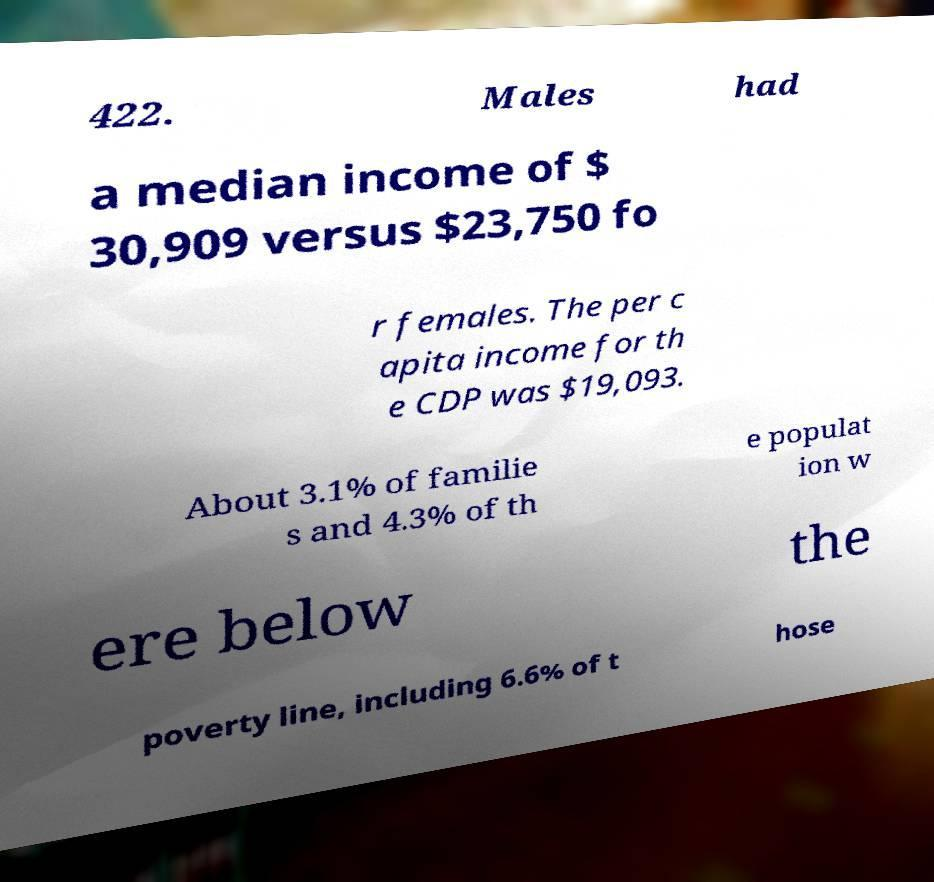Could you extract and type out the text from this image? 422. Males had a median income of $ 30,909 versus $23,750 fo r females. The per c apita income for th e CDP was $19,093. About 3.1% of familie s and 4.3% of th e populat ion w ere below the poverty line, including 6.6% of t hose 